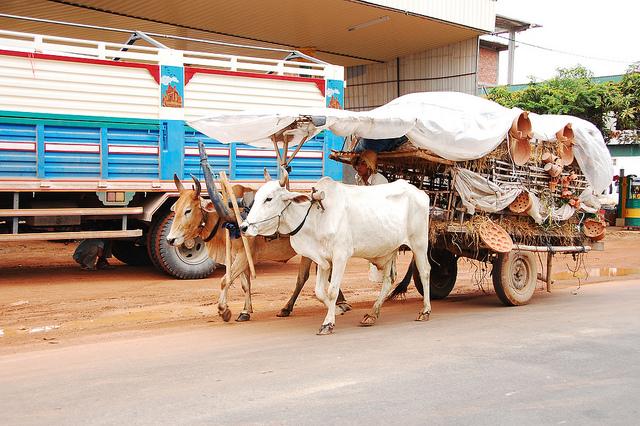What type of animal is in the picture?
Concise answer only. Cows. What is being pulled?
Quick response, please. Cart. What color is the truck?
Give a very brief answer. Blue and white. 